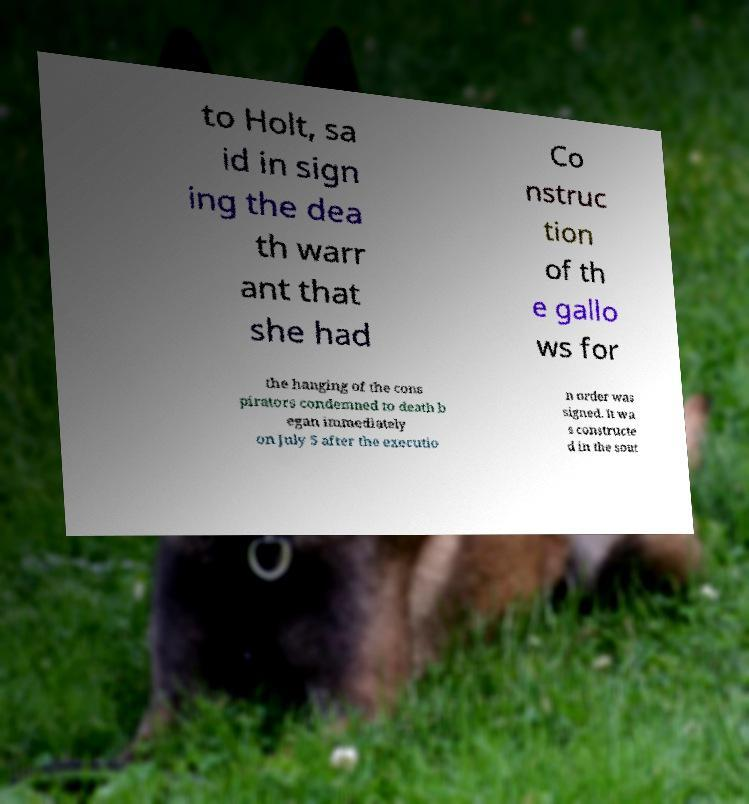There's text embedded in this image that I need extracted. Can you transcribe it verbatim? to Holt, sa id in sign ing the dea th warr ant that she had Co nstruc tion of th e gallo ws for the hanging of the cons pirators condemned to death b egan immediately on July 5 after the executio n order was signed. It wa s constructe d in the sout 